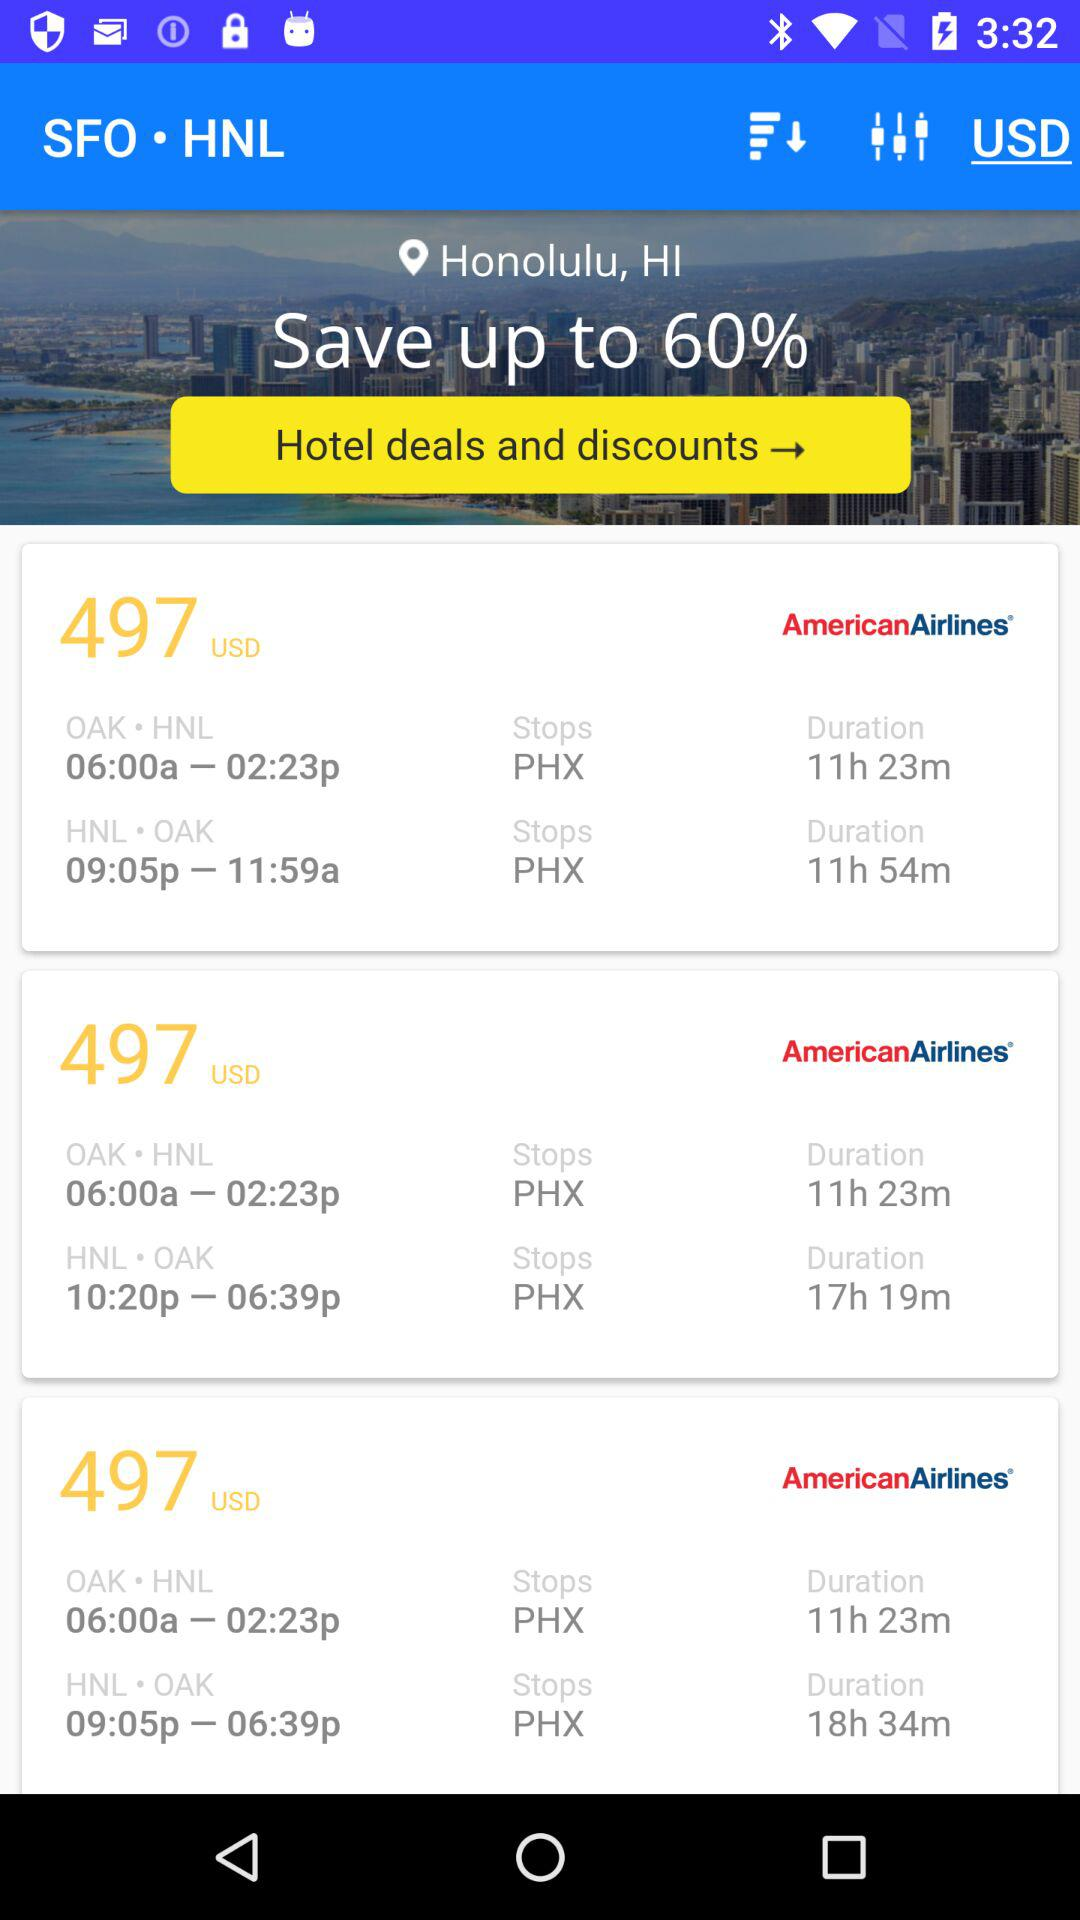What's the departure time from "Oakland Airport"? The departure time from "Oakland Airport" is 6 a.m. 